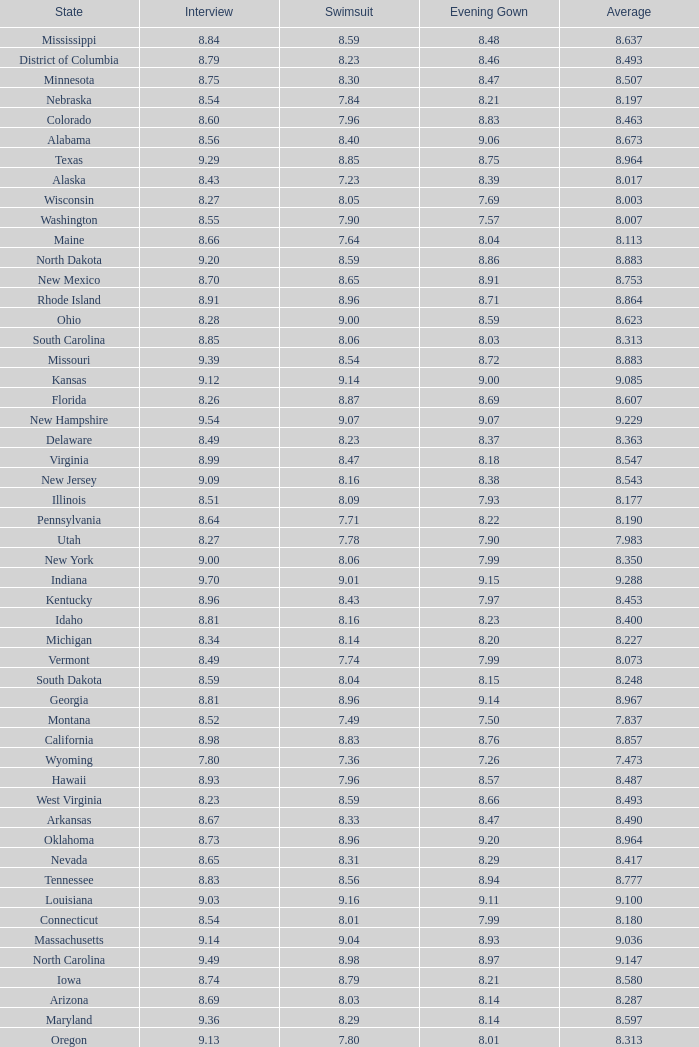Name the state with an evening gown more than 8.86 and interview less than 8.7 and swimsuit less than 8.96 Alabama. 